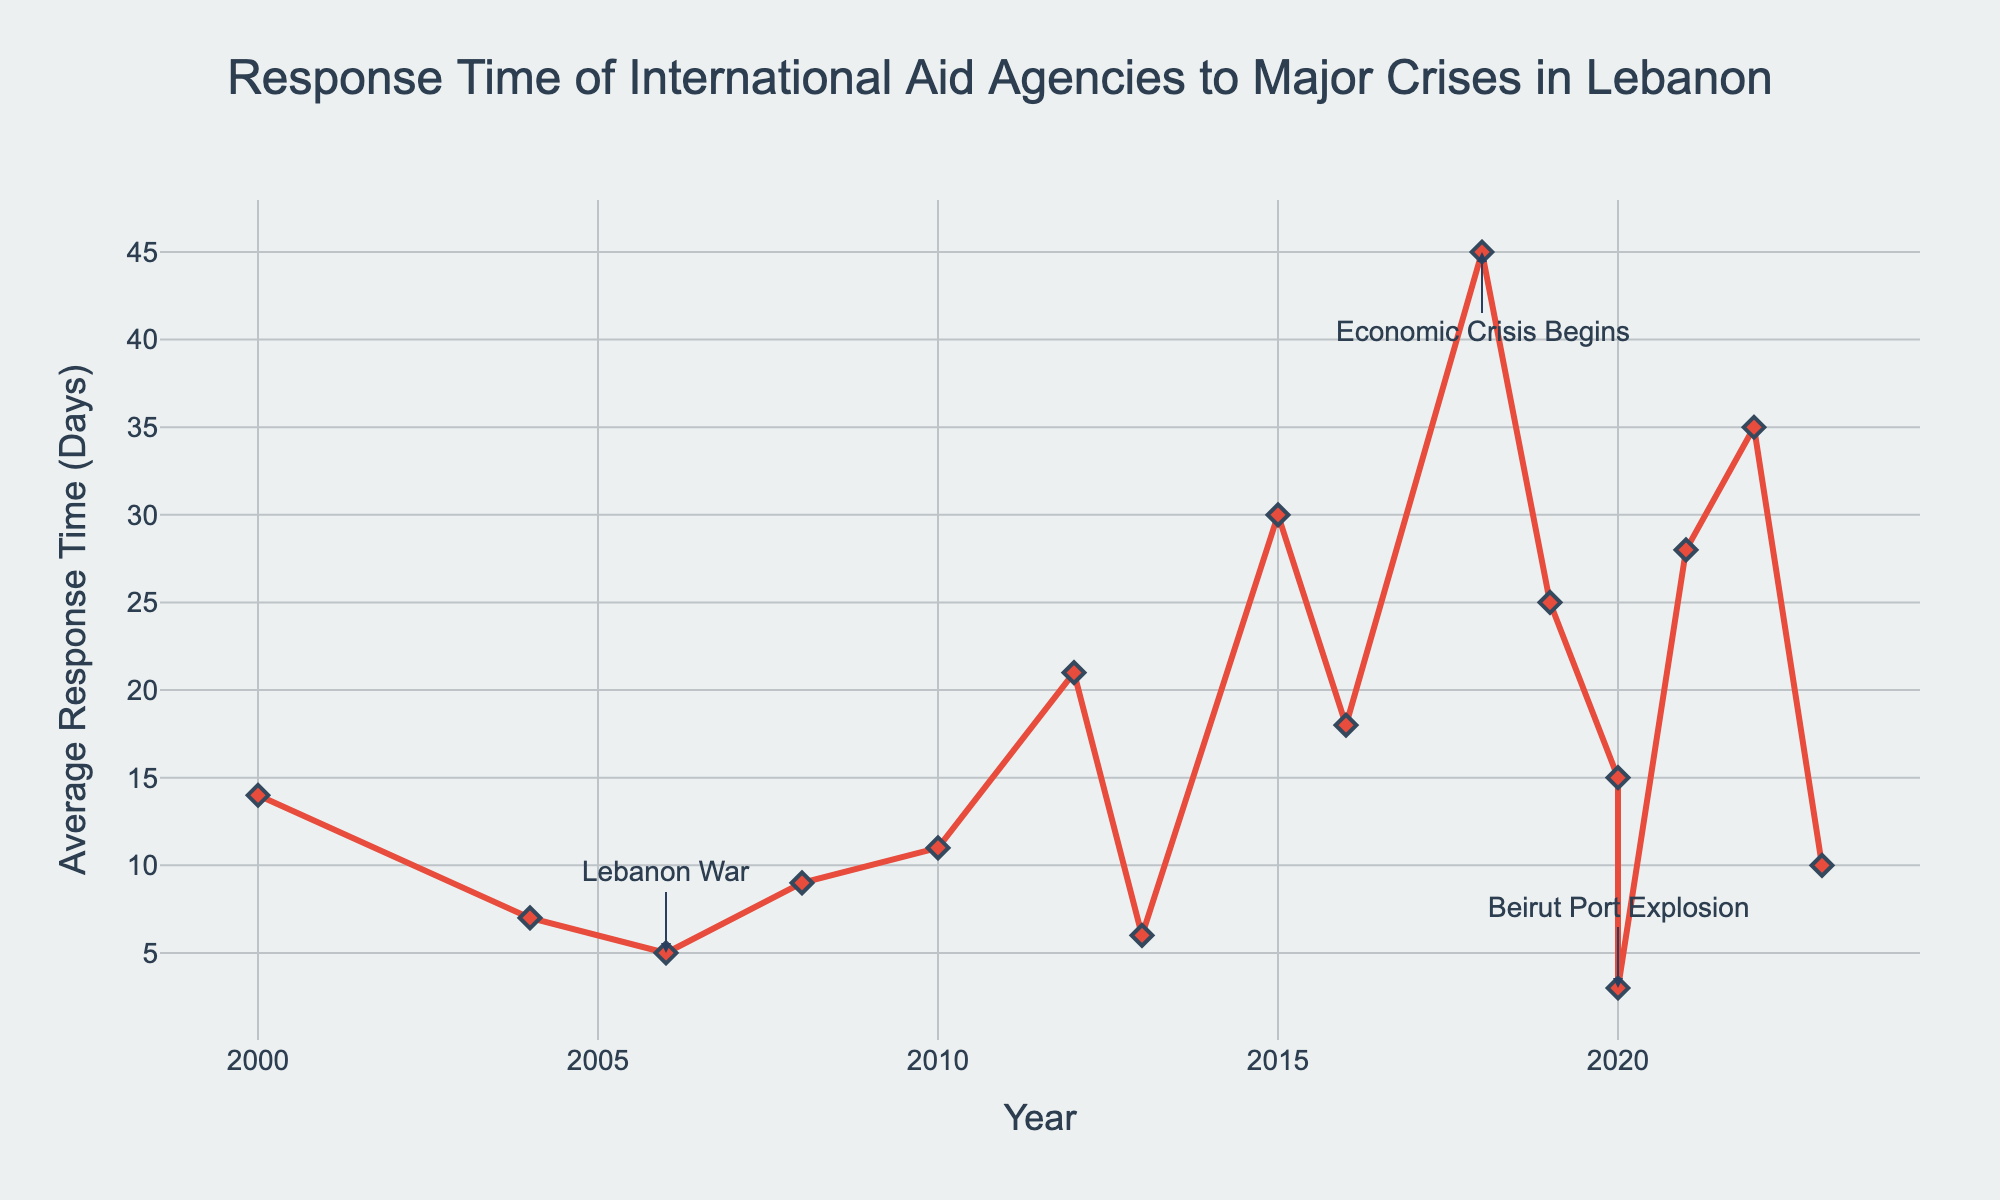What's the shortest response time recorded? The shortest response time can be identified by looking for the smallest y-value on the chart. In the figure, the lowest point is at 3 days for the Beirut Port Explosion in 2020.
Answer: 3 days Which crisis had the longest average response time and how long was it? To determine the longest response time, look for the highest y-value on the chart. The highest point corresponds to the Economic Crisis Begins in 2018, with an average response time of 45 days.
Answer: Economic Crisis Begins, 45 days How did the average response time change from the South Lebanon Conflict in 2000 to the Garbage Crisis in 2015? First, identify the y-values for both the South Lebanon Conflict in 2000 and the Garbage Crisis in 2015. The response time in 2000 was 14 days, and in 2015, it was 30 days. Compute the difference: 30 - 14 = 16. Therefore, the response time increased by 16 days.
Answer: Increased by 16 days Which crisis in the years 2020 had the faster response time, the COVID-19 Pandemic or the Beirut Port Explosion? By how many days did they differ? Identify the y-values for both the COVID-19 Pandemic and the Beirut Port Explosion in 2020. The COVID-19 Pandemic had a response time of 15 days, and the Beirut Port Explosion had a response time of 3 days. Compute the difference: 15 - 3 = 12. Therefore, the Beirut Port Explosion had a faster response time by 12 days.
Answer: Beirut Port Explosion, 12 days What is the average response time over the entire period from 2000 to 2023? Sum all the average response times and divide by the number of crises. Sum: 14 + 7 + 5 + 9 + 11 + 21 + 6 + 30 + 18 + 45 + 25 + 15 + 3 + 28 + 35 + 10 = 282. There are 16 crises, so the average is 282 / 16 = 17.625.
Answer: 17.625 days Compare the response times for the Syrian Refugee Crisis in 2012 and at its peak in 2016. By how many days did they differ? Identify the y-values for both points. In 2012, the response time was 21 days, and in 2016, it was 18 days. Compute the difference: 21 - 18 = 3. Therefore, the response time decreased by 3 days.
Answer: Decreased by 3 days Which year had the highest number of major crises and what were their average response times? Look for the year with multiple data points. In 2020, there were two major crises: the COVID-19 Pandemic with 15 days and the Beirut Port Explosion with 3 days.
Answer: 2020, 15 days and 3 days Did the response times show a general increasing or decreasing trend from 2000 to 2023? Examine the overall direction of the line chart from left (2000) to right (2023). The response time appears to fluctuate with no clear consistent trend, but notable peaks can be seen in recent years, especially in 2015, 2018, 2019, 2021, and 2022.
Answer: Fluctuating trend with recent peaks 